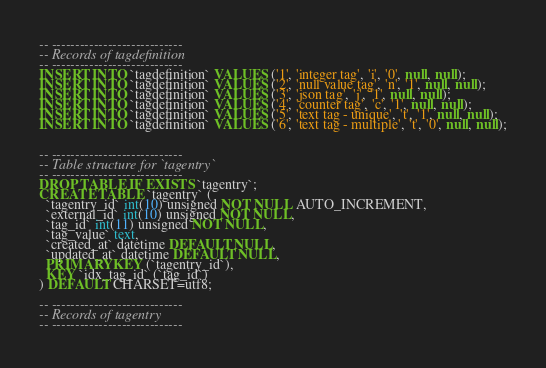Convert code to text. <code><loc_0><loc_0><loc_500><loc_500><_SQL_>
-- ----------------------------
-- Records of tagdefinition
-- ----------------------------
INSERT INTO `tagdefinition` VALUES ('1', 'integer tag', 'i', '0', null, null);
INSERT INTO `tagdefinition` VALUES ('2', 'null value tag', 'n', '1', null, null);
INSERT INTO `tagdefinition` VALUES ('3', 'json tag', 'j', '1', null, null);
INSERT INTO `tagdefinition` VALUES ('4', 'counter tag', 'c', '1', null, null);
INSERT INTO `tagdefinition` VALUES ('5', 'text tag - unique', 't', '1', null, null);
INSERT INTO `tagdefinition` VALUES ('6', 'text tag - multiple', 't', '0', null, null);


-- ----------------------------
-- Table structure for `tagentry`
-- ----------------------------
DROP TABLE IF EXISTS `tagentry`;
CREATE TABLE `tagentry` (
  `tagentry_id` int(10) unsigned NOT NULL AUTO_INCREMENT,
  `external_id` int(10) unsigned NOT NULL,
  `tag_id` int(11) unsigned NOT NULL,
  `tag_value` text,
  `created_at` datetime DEFAULT NULL,
  `updated_at` datetime DEFAULT NULL,
  PRIMARY KEY (`tagentry_id`),
  KEY `idx_tag_id` (`tag_id`)
) DEFAULT CHARSET=utf8;

-- ----------------------------
-- Records of tagentry
-- ----------------------------
</code> 